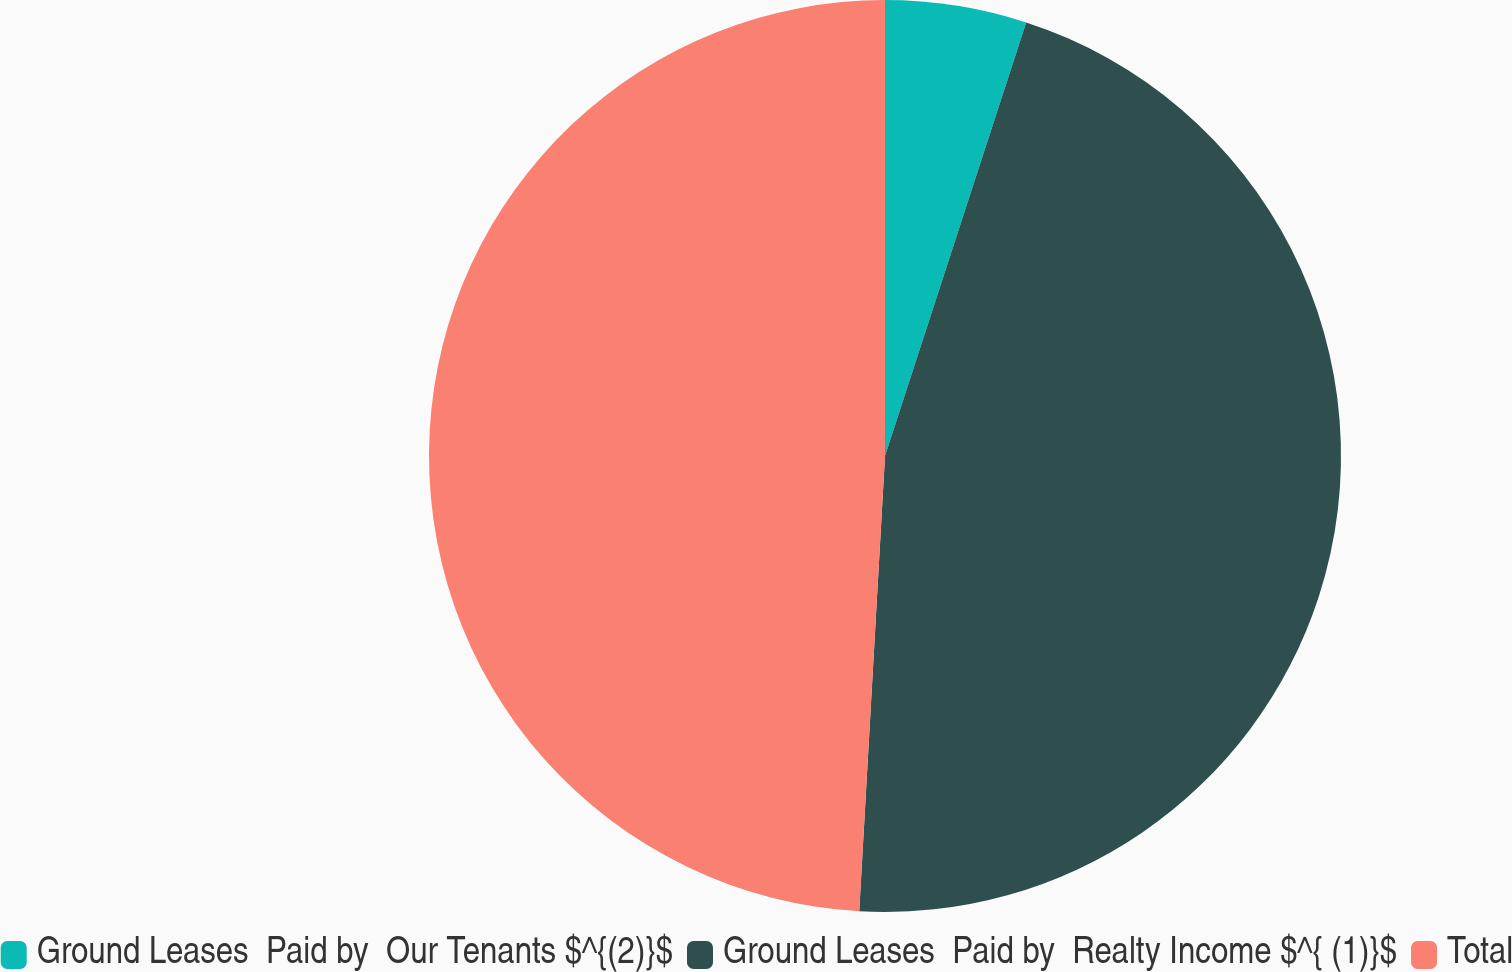<chart> <loc_0><loc_0><loc_500><loc_500><pie_chart><fcel>Ground Leases  Paid by  Our Tenants $^{(2)}$<fcel>Ground Leases  Paid by  Realty Income $^{ (1)}$<fcel>Total<nl><fcel>5.01%<fcel>45.89%<fcel>49.1%<nl></chart> 